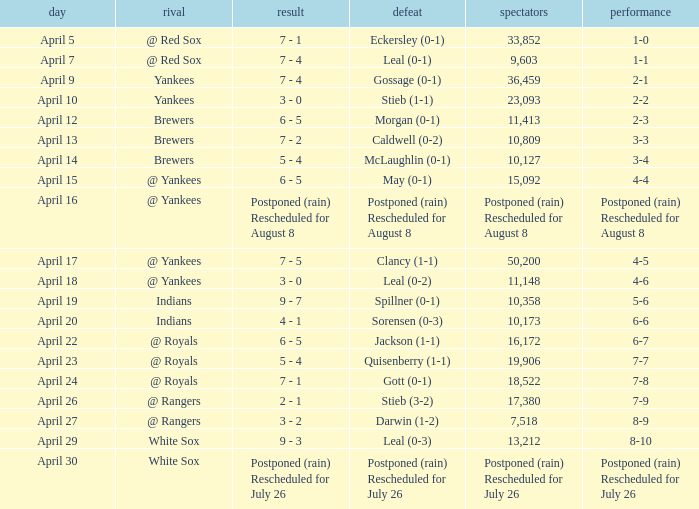What was the score of the game attended by 50,200? 7 - 5. 